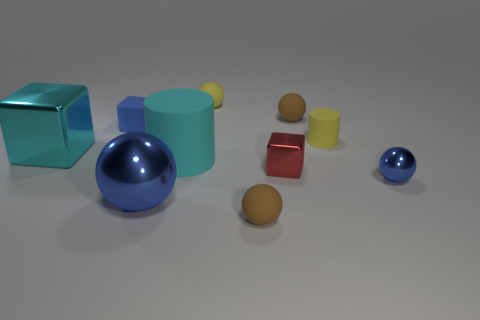There is a large rubber cylinder on the right side of the large blue thing; is its color the same as the metal block on the left side of the small shiny block?
Give a very brief answer. Yes. What is the material of the small block that is the same color as the big metal sphere?
Offer a very short reply. Rubber. How many matte objects are either large gray things or tiny blue spheres?
Provide a short and direct response. 0. The red shiny object has what size?
Your answer should be very brief. Small. What number of things are either brown balls or balls to the right of the big blue shiny thing?
Your response must be concise. 4. How many other objects are there of the same color as the large rubber cylinder?
Your response must be concise. 1. Does the matte cube have the same size as the blue metal thing that is to the left of the red metallic object?
Your answer should be very brief. No. Do the blue shiny thing left of the yellow rubber cylinder and the tiny blue metal sphere have the same size?
Make the answer very short. No. How many other objects are there of the same material as the small cylinder?
Provide a short and direct response. 5. Are there an equal number of cubes to the right of the tiny yellow rubber cylinder and things that are on the left side of the tiny blue ball?
Make the answer very short. No. 